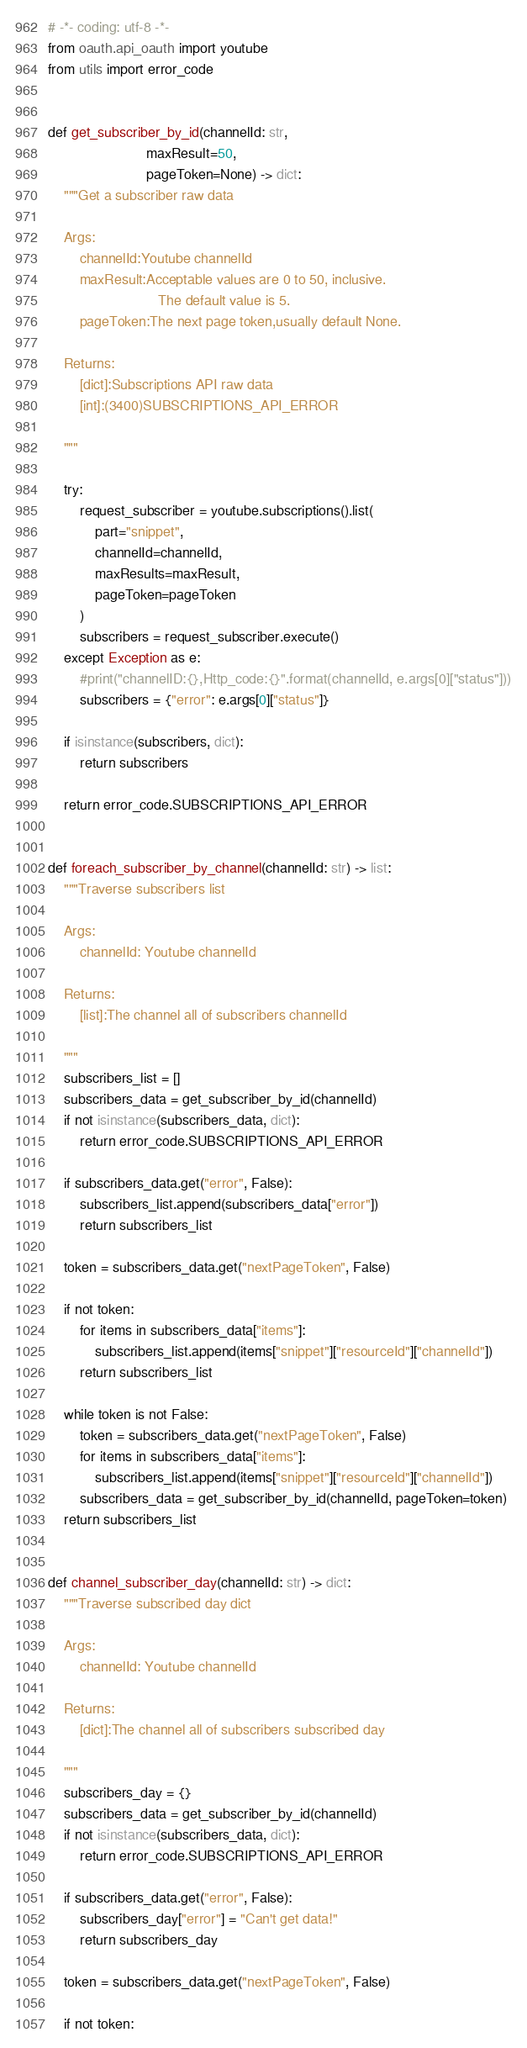Convert code to text. <code><loc_0><loc_0><loc_500><loc_500><_Python_># -*- coding: utf-8 -*-
from oauth.api_oauth import youtube
from utils import error_code


def get_subscriber_by_id(channelId: str,
                         maxResult=50,
                         pageToken=None) -> dict:
    """Get a subscriber raw data

    Args:
        channelId:Youtube channelId
        maxResult:Acceptable values are 0 to 50, inclusive.
                            The default value is 5.
        pageToken:The next page token,usually default None.

    Returns:
        [dict]:Subscriptions API raw data
        [int]:(3400)SUBSCRIPTIONS_API_ERROR

    """
    
    try:
        request_subscriber = youtube.subscriptions().list(
            part="snippet",
            channelId=channelId,
            maxResults=maxResult,
            pageToken=pageToken
        )
        subscribers = request_subscriber.execute()
    except Exception as e:
        #print("channelID:{},Http_code:{}".format(channelId, e.args[0]["status"]))
        subscribers = {"error": e.args[0]["status"]}

    if isinstance(subscribers, dict):
        return subscribers

    return error_code.SUBSCRIPTIONS_API_ERROR


def foreach_subscriber_by_channel(channelId: str) -> list:
    """Traverse subscribers list

    Args:
        channelId: Youtube channelId

    Returns:
        [list]:The channel all of subscribers channelId

    """
    subscribers_list = []
    subscribers_data = get_subscriber_by_id(channelId)
    if not isinstance(subscribers_data, dict):
        return error_code.SUBSCRIPTIONS_API_ERROR

    if subscribers_data.get("error", False):
        subscribers_list.append(subscribers_data["error"])
        return subscribers_list

    token = subscribers_data.get("nextPageToken", False)

    if not token:
        for items in subscribers_data["items"]:
            subscribers_list.append(items["snippet"]["resourceId"]["channelId"])
        return subscribers_list

    while token is not False:
        token = subscribers_data.get("nextPageToken", False)
        for items in subscribers_data["items"]:
            subscribers_list.append(items["snippet"]["resourceId"]["channelId"])
        subscribers_data = get_subscriber_by_id(channelId, pageToken=token)
    return subscribers_list


def channel_subscriber_day(channelId: str) -> dict:
    """Traverse subscribed day dict

    Args:
        channelId: Youtube channelId

    Returns:
        [dict]:The channel all of subscribers subscribed day

    """
    subscribers_day = {}
    subscribers_data = get_subscriber_by_id(channelId)
    if not isinstance(subscribers_data, dict):
        return error_code.SUBSCRIPTIONS_API_ERROR

    if subscribers_data.get("error", False):
        subscribers_day["error"] = "Can't get data!"
        return subscribers_day

    token = subscribers_data.get("nextPageToken", False)

    if not token:</code> 